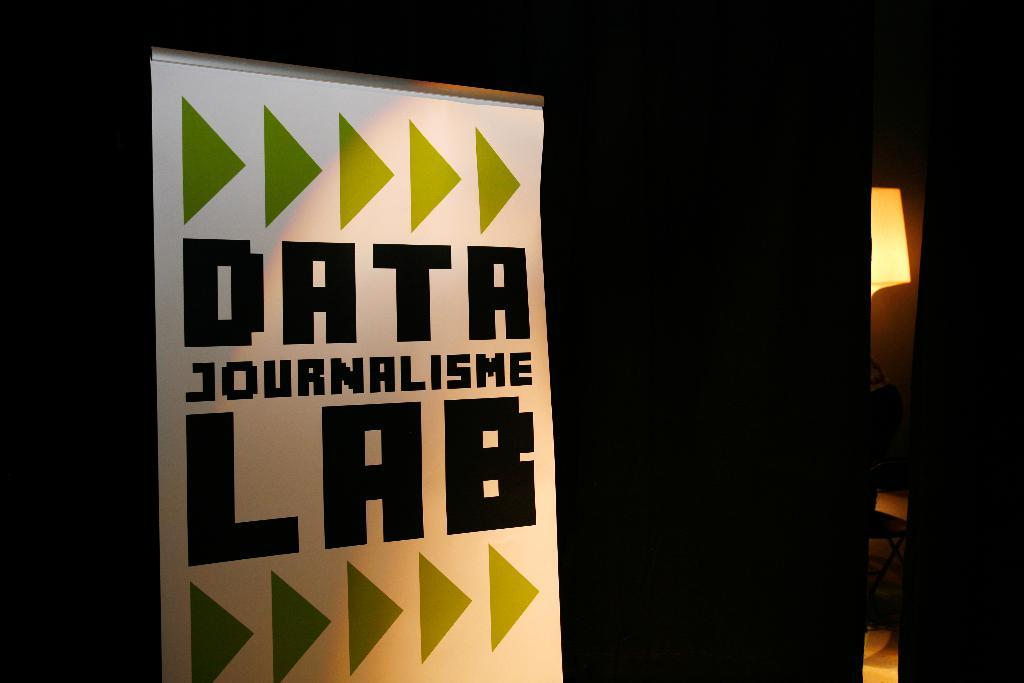<image>
Write a terse but informative summary of the picture. poster with green arrors pointing to the data journalisme lab 